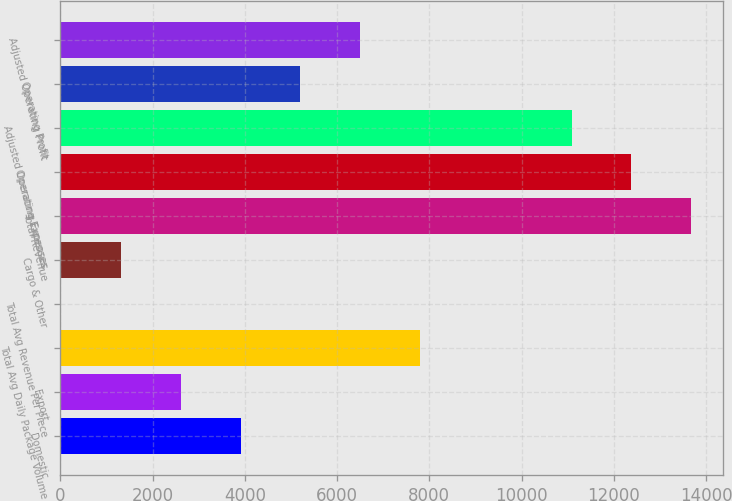Convert chart. <chart><loc_0><loc_0><loc_500><loc_500><bar_chart><fcel>Domestic<fcel>Export<fcel>Total Avg Daily Package Volume<fcel>Total Avg Revenue Per Piece<fcel>Cargo & Other<fcel>Total Revenue<fcel>Operating Expenses<fcel>Adjusted Operating Expenses<fcel>Operating Profit<fcel>Adjusted Operating Profit<nl><fcel>3909.11<fcel>2612.12<fcel>7800.08<fcel>18.15<fcel>1315.14<fcel>13677<fcel>12380<fcel>11083<fcel>5206.1<fcel>6503.09<nl></chart> 